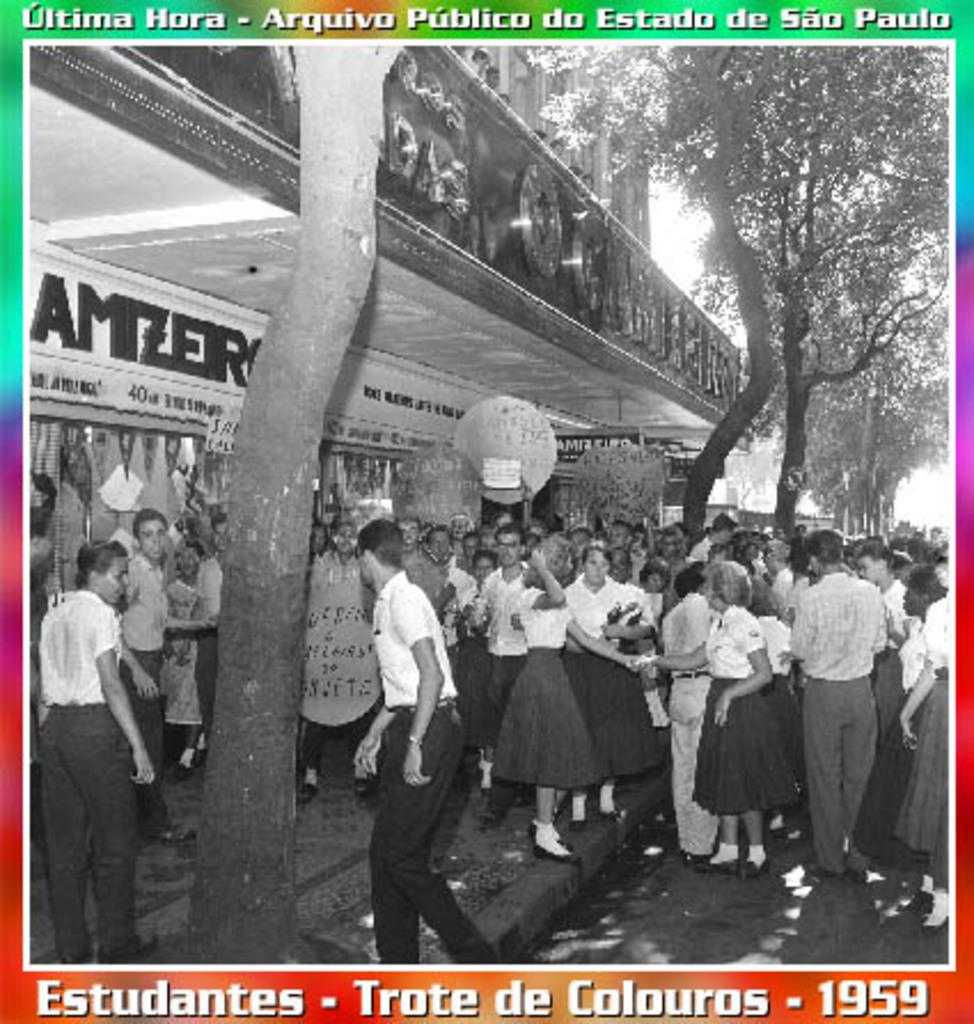What is happening in the image? There are people standing in the image. What can be seen in the left corner of the image? There is a store in the left corner of the image. What is visible in the background of the image? There are trees in the background of the image. What is written above and below the store? There is text written above and below the store. What type of juice is being sold at the store in the image? There is no juice being sold at the store in the image; the text above and below the store does not mention any specific products. 